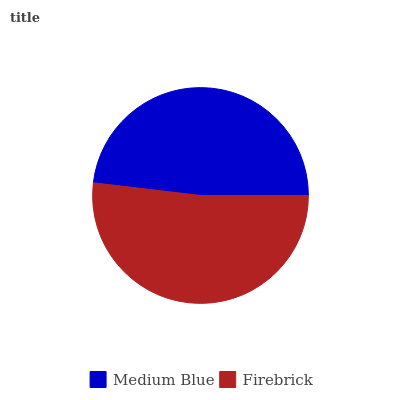Is Medium Blue the minimum?
Answer yes or no. Yes. Is Firebrick the maximum?
Answer yes or no. Yes. Is Firebrick the minimum?
Answer yes or no. No. Is Firebrick greater than Medium Blue?
Answer yes or no. Yes. Is Medium Blue less than Firebrick?
Answer yes or no. Yes. Is Medium Blue greater than Firebrick?
Answer yes or no. No. Is Firebrick less than Medium Blue?
Answer yes or no. No. Is Firebrick the high median?
Answer yes or no. Yes. Is Medium Blue the low median?
Answer yes or no. Yes. Is Medium Blue the high median?
Answer yes or no. No. Is Firebrick the low median?
Answer yes or no. No. 